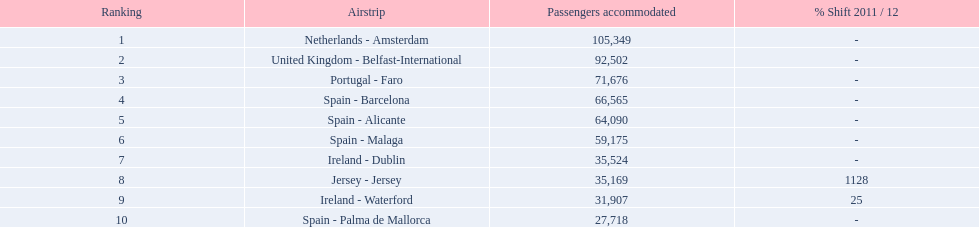What are all of the routes out of the london southend airport? Netherlands - Amsterdam, United Kingdom - Belfast-International, Portugal - Faro, Spain - Barcelona, Spain - Alicante, Spain - Malaga, Ireland - Dublin, Jersey - Jersey, Ireland - Waterford, Spain - Palma de Mallorca. How many passengers have traveled to each destination? 105,349, 92,502, 71,676, 66,565, 64,090, 59,175, 35,524, 35,169, 31,907, 27,718. And which destination has been the most popular to passengers? Netherlands - Amsterdam. 